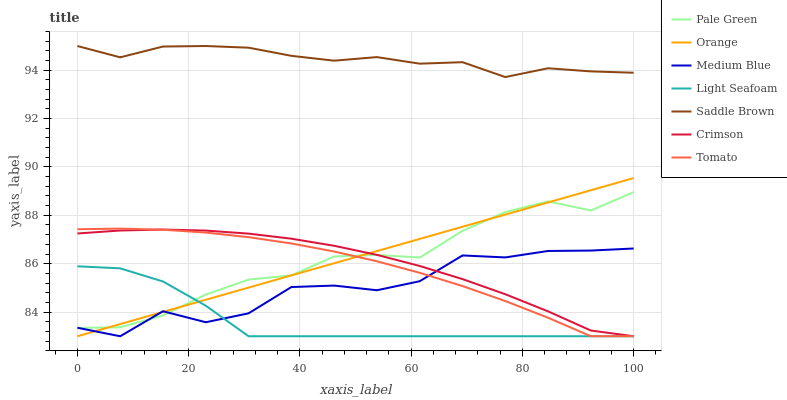Does Light Seafoam have the minimum area under the curve?
Answer yes or no. Yes. Does Saddle Brown have the maximum area under the curve?
Answer yes or no. Yes. Does Medium Blue have the minimum area under the curve?
Answer yes or no. No. Does Medium Blue have the maximum area under the curve?
Answer yes or no. No. Is Orange the smoothest?
Answer yes or no. Yes. Is Medium Blue the roughest?
Answer yes or no. Yes. Is Crimson the smoothest?
Answer yes or no. No. Is Crimson the roughest?
Answer yes or no. No. Does Pale Green have the lowest value?
Answer yes or no. No. Does Medium Blue have the highest value?
Answer yes or no. No. Is Pale Green less than Saddle Brown?
Answer yes or no. Yes. Is Saddle Brown greater than Pale Green?
Answer yes or no. Yes. Does Pale Green intersect Saddle Brown?
Answer yes or no. No. 